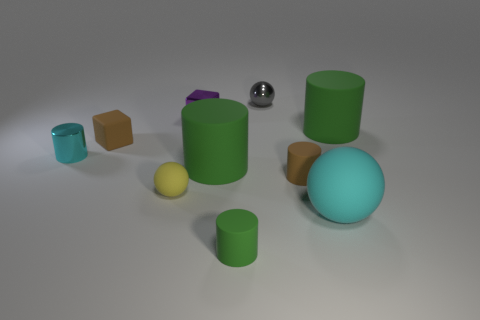Subtract all small metal cylinders. How many cylinders are left? 4 Subtract all green spheres. How many green cylinders are left? 3 Subtract 1 balls. How many balls are left? 2 Subtract all cyan cylinders. How many cylinders are left? 4 Subtract all cubes. How many objects are left? 8 Subtract all green balls. Subtract all red cylinders. How many balls are left? 3 Subtract all big cyan balls. Subtract all tiny cyan metal objects. How many objects are left? 8 Add 5 small green cylinders. How many small green cylinders are left? 6 Add 1 tiny gray metal balls. How many tiny gray metal balls exist? 2 Subtract 0 purple spheres. How many objects are left? 10 